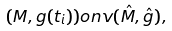<formula> <loc_0><loc_0><loc_500><loc_500>( M , g ( t _ { i } ) ) o n v ( \hat { M } , \hat { g } ) ,</formula> 